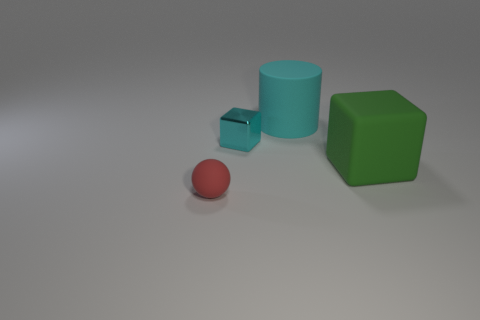Add 3 tiny objects. How many objects exist? 7 Subtract all tiny cyan objects. Subtract all big yellow metallic cylinders. How many objects are left? 3 Add 4 big green matte things. How many big green matte things are left? 5 Add 1 red objects. How many red objects exist? 2 Subtract 1 red balls. How many objects are left? 3 